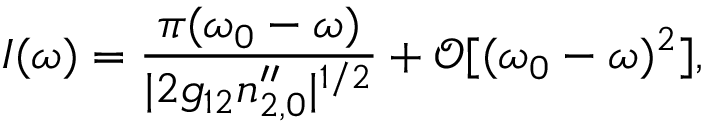Convert formula to latex. <formula><loc_0><loc_0><loc_500><loc_500>I ( \omega ) = \frac { \pi ( \omega _ { 0 } - \omega ) } { | 2 g _ { 1 2 } n _ { 2 , 0 } ^ { \prime \prime } | ^ { 1 / 2 } } + \mathcal { O } [ ( \omega _ { 0 } - \omega ) ^ { 2 } ] ,</formula> 